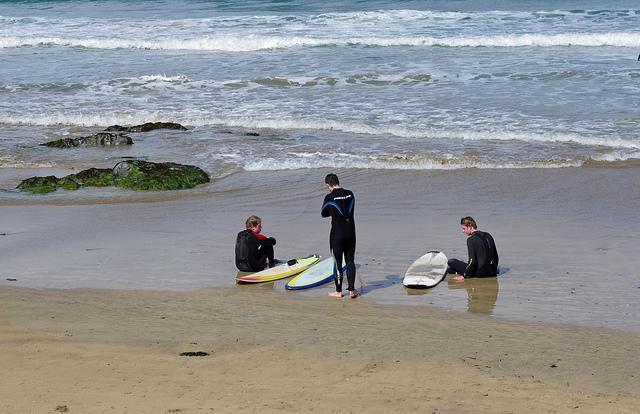How many people are in  the photo?
Give a very brief answer. 3. How many people are sitting on surfboards?
Give a very brief answer. 0. 